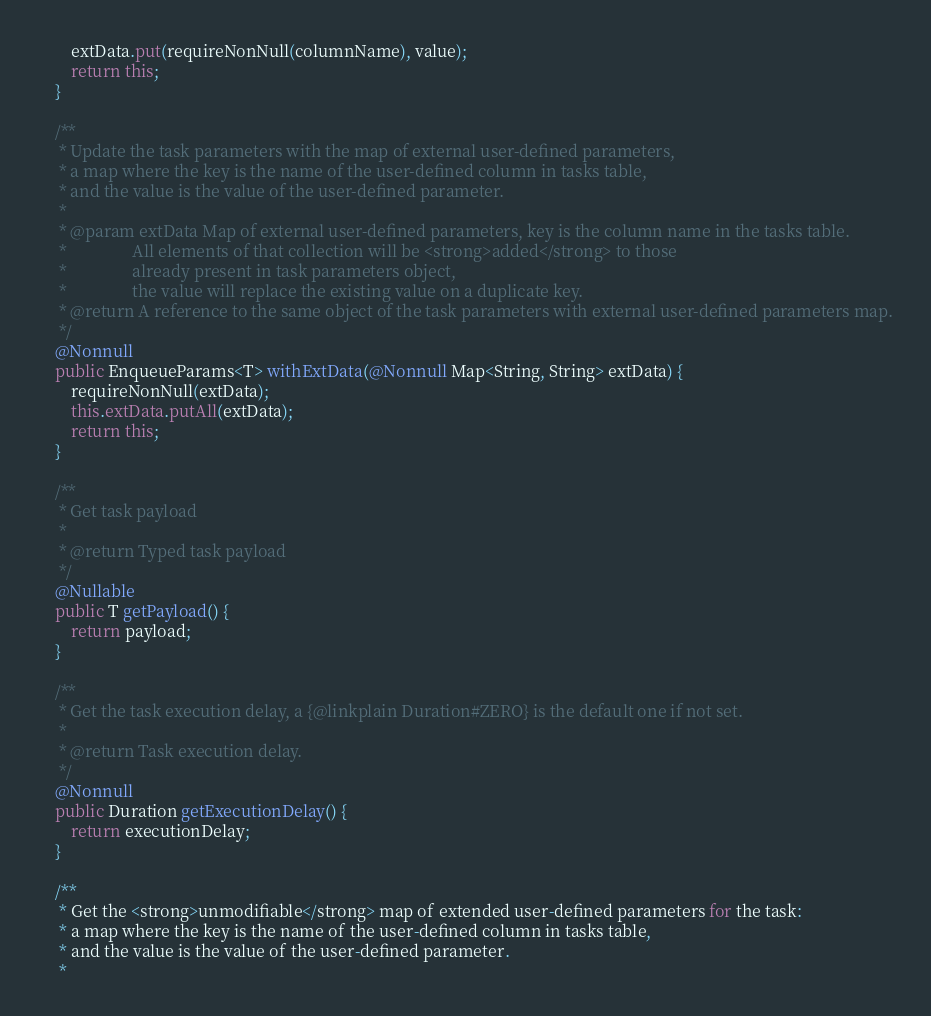<code> <loc_0><loc_0><loc_500><loc_500><_Java_>        extData.put(requireNonNull(columnName), value);
        return this;
    }

    /**
     * Update the task parameters with the map of external user-defined parameters,
     * a map where the key is the name of the user-defined column in tasks table,
     * and the value is the value of the user-defined parameter.
     *
     * @param extData Map of external user-defined parameters, key is the column name in the tasks table.
     *                All elements of that collection will be <strong>added</strong> to those
     *                already present in task parameters object,
     *                the value will replace the existing value on a duplicate key.
     * @return A reference to the same object of the task parameters with external user-defined parameters map.
     */
    @Nonnull
    public EnqueueParams<T> withExtData(@Nonnull Map<String, String> extData) {
        requireNonNull(extData);
        this.extData.putAll(extData);
        return this;
    }

    /**
     * Get task payload
     *
     * @return Typed task payload
     */
    @Nullable
    public T getPayload() {
        return payload;
    }

    /**
     * Get the task execution delay, a {@linkplain Duration#ZERO} is the default one if not set.
     *
     * @return Task execution delay.
     */
    @Nonnull
    public Duration getExecutionDelay() {
        return executionDelay;
    }

    /**
     * Get the <strong>unmodifiable</strong> map of extended user-defined parameters for the task:
     * a map where the key is the name of the user-defined column in tasks table,
     * and the value is the value of the user-defined parameter.
     *</code> 